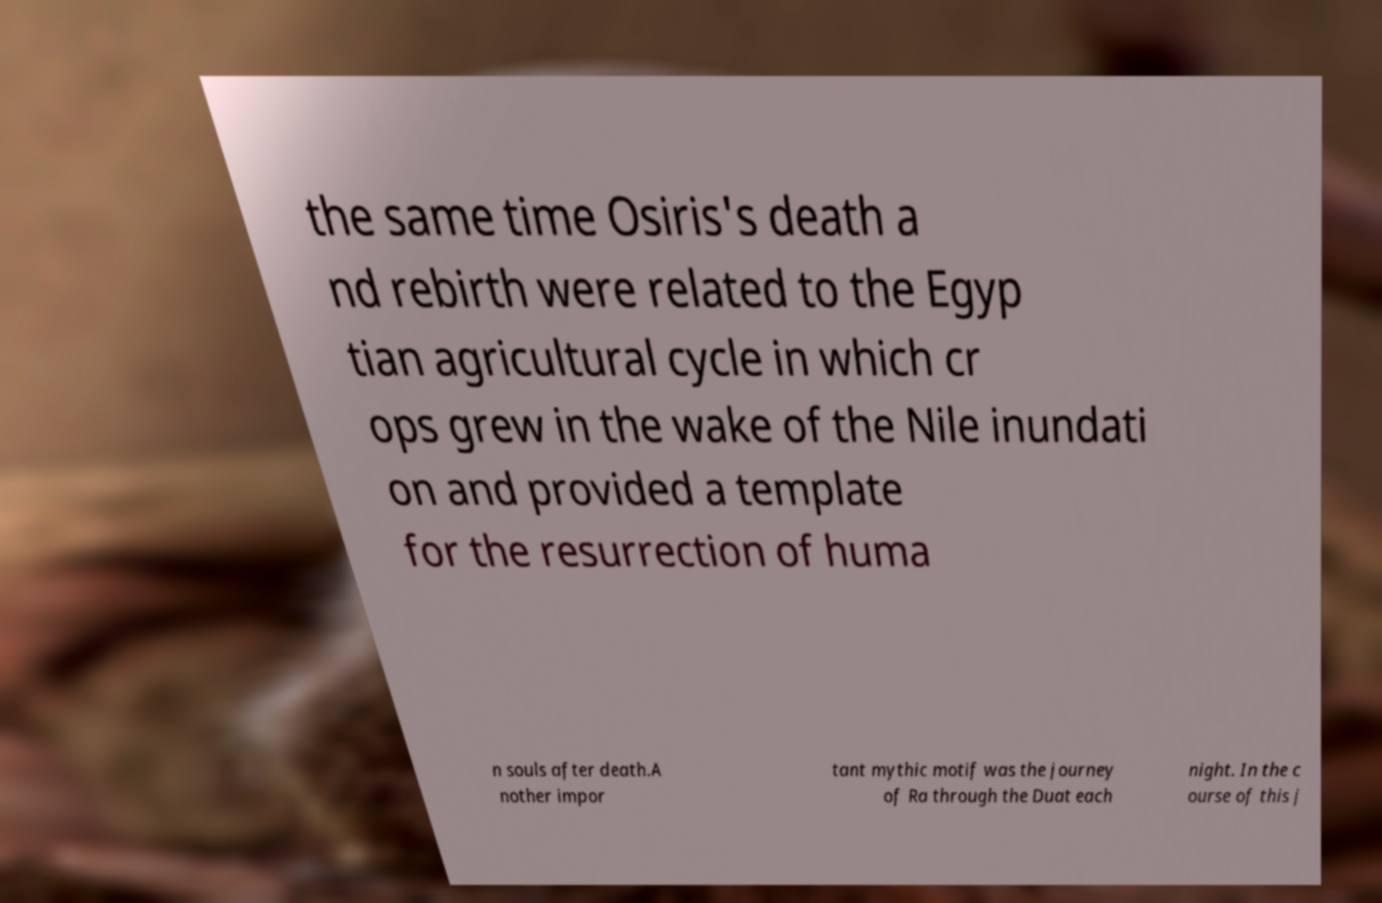What messages or text are displayed in this image? I need them in a readable, typed format. the same time Osiris's death a nd rebirth were related to the Egyp tian agricultural cycle in which cr ops grew in the wake of the Nile inundati on and provided a template for the resurrection of huma n souls after death.A nother impor tant mythic motif was the journey of Ra through the Duat each night. In the c ourse of this j 